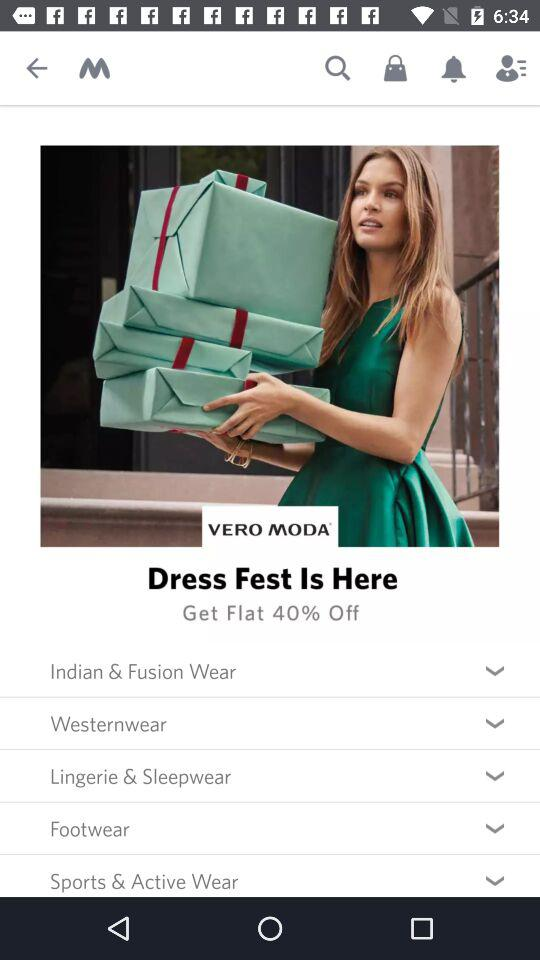How much is the discount in the "Dress Fest"? There is a flat 40% discount. 